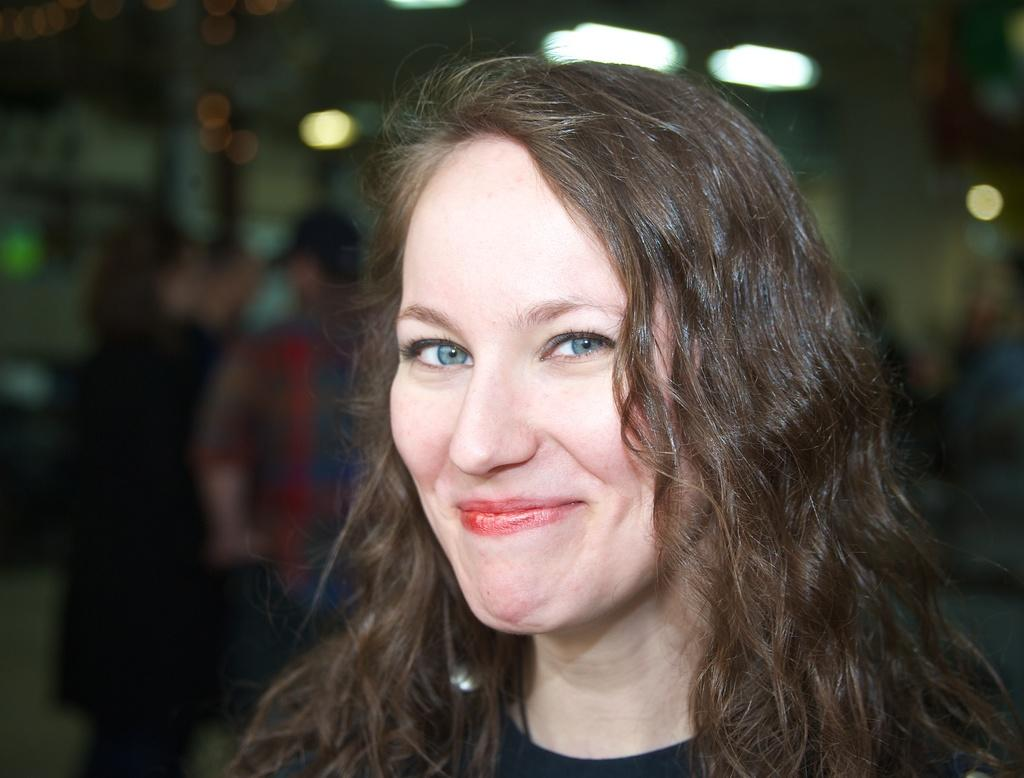Who is the main subject in the image? There is a woman in the image. Can you describe the woman's appearance? The woman has long hair and is wearing a black dress. What else can be seen in the image? There is a group of people in the background of the image. What type of hook is the woman using to hang her belief in the image? There is no hook or belief present in the image; it features a woman with long hair and a black dress, along with a group of people in the background. 